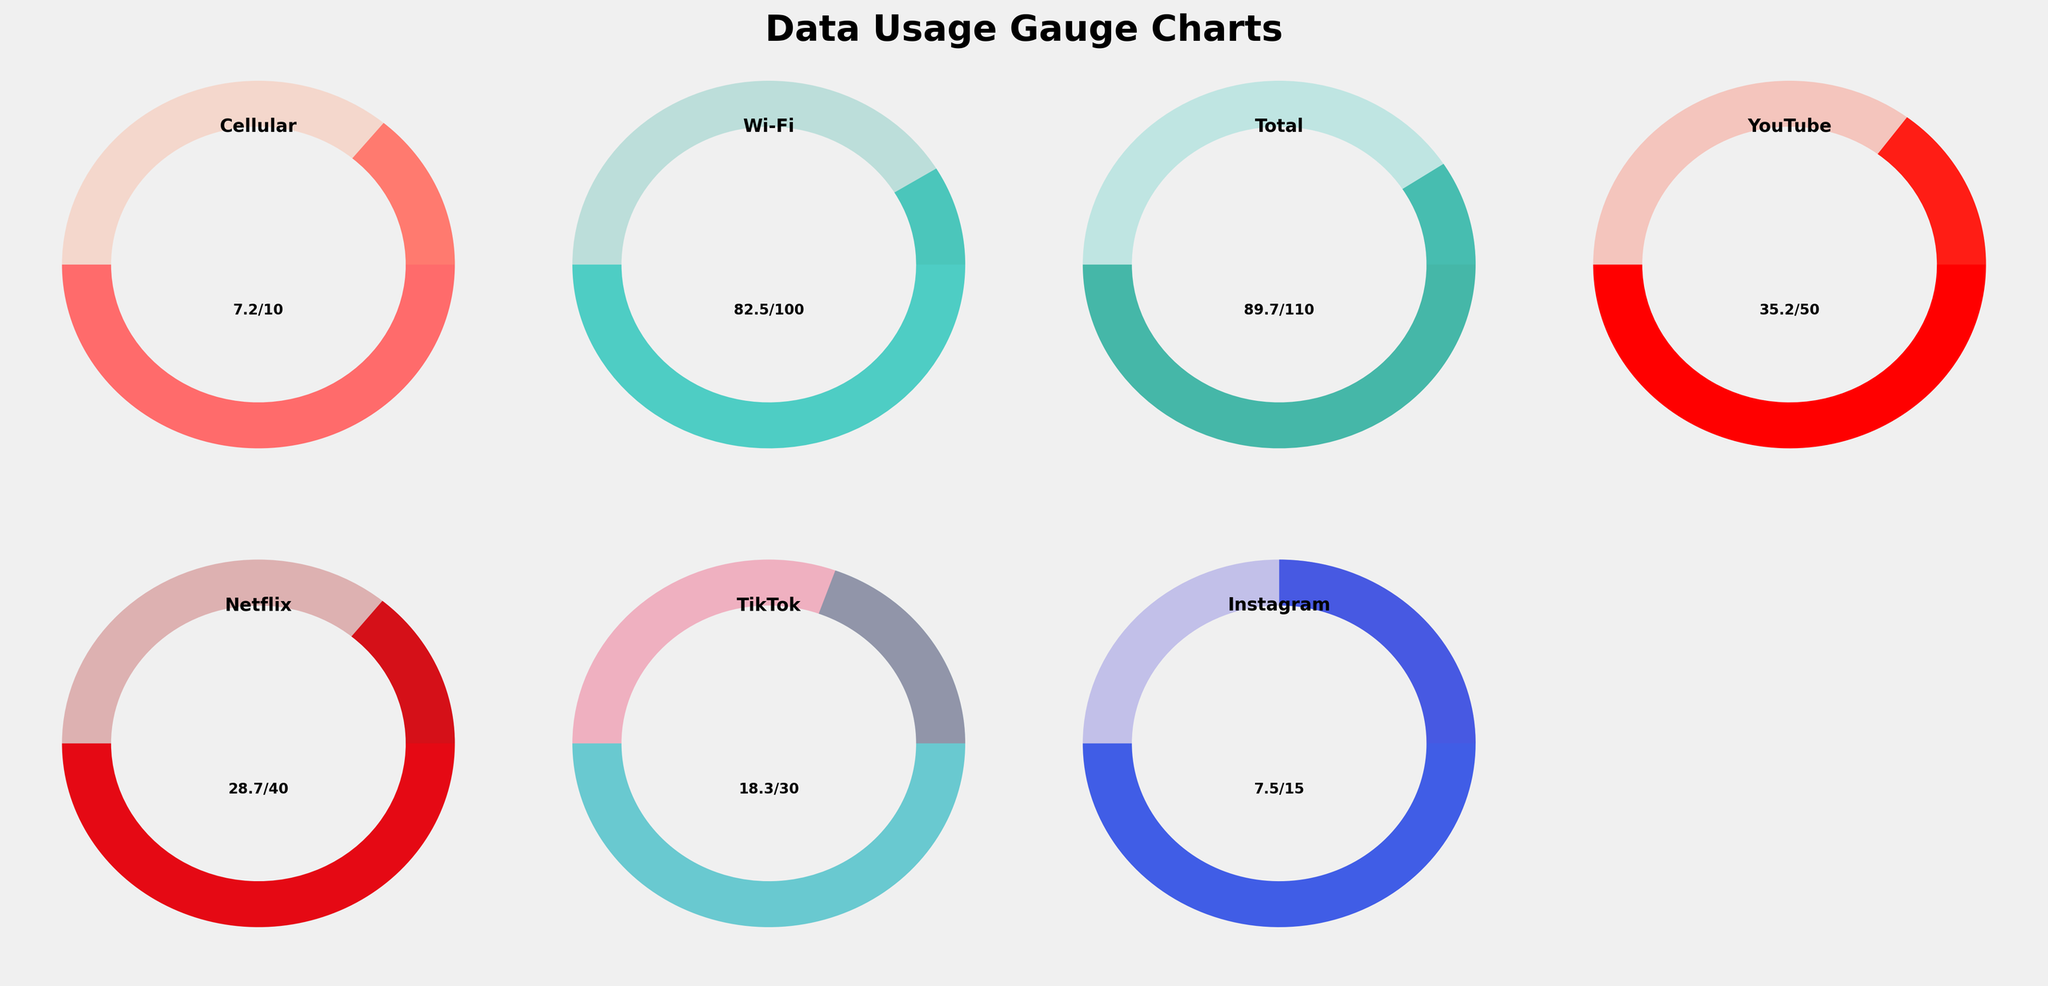What is the data usage limit for Wi-Fi? From the gauge chart for Wi-Fi, the limit is shown as 100.
Answer: 100 What is the current cellular data usage? The gauge chart for Cellular shows the usage as 7.2.
Answer: 7.2 Which service has used more data: Instagram or TikTok? Comparing the gauges for Instagram and TikTok, Instagram has 7.5 used while TikTok has 18.3 used. TikTok is higher.
Answer: TikTok What fraction of its limit has YouTube used? YouTube usage is 35.2 out of a limit of 50. The fraction is 35.2/50 = 0.704.
Answer: 0.704 How much more data can Netflix use before reaching its limit? Netflix has used 28.7 out of 40. The remaining data is 40 - 28.7 = 11.3.
Answer: 11.3 Between Cellular and Wi-Fi, which has a higher percentage of its limit used? Cellular has used 7.2 out of 10 (72%), and Wi-Fi has used 82.5 out of 100 (82.5%). Wi-Fi has a higher percentage.
Answer: Wi-Fi What is the sum of data usage for YouTube and Netflix? The usage values are 35.2 for YouTube and 28.7 for Netflix. The sum is 35.2 + 28.7 = 63.9.
Answer: 63.9 Which data type is closest to reaching its limit? Gauging visually, YouTube shows the closest proportion used relative to its limit (35.2/50 = 0.704 or 70.4%).
Answer: YouTube Is the total data usage beyond half of its limit? Total data usage is 89.7 out of 110. Half the limit is 55. Since 89.7 > 55, it is beyond half.
Answer: Yes How much more data has been used in Wi-Fi compared to Cellular? Wi-Fi usage is 82.5, and Cellular is 7.2. The difference is 82.5 - 7.2 = 75.3.
Answer: 75.3 